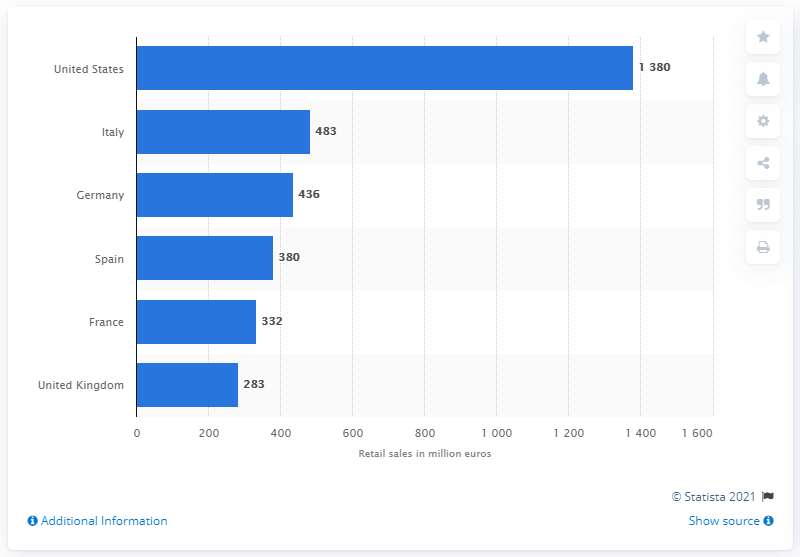Outline some significant characteristics in this image. In 2013, the German plano sunwear market had a value of approximately 436. 